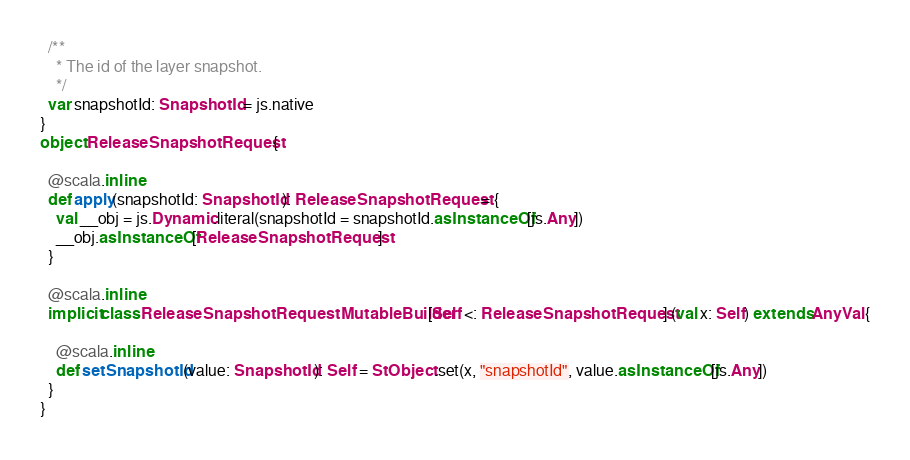Convert code to text. <code><loc_0><loc_0><loc_500><loc_500><_Scala_>  /**
    * The id of the layer snapshot.
    */
  var snapshotId: SnapshotId = js.native
}
object ReleaseSnapshotRequest {
  
  @scala.inline
  def apply(snapshotId: SnapshotId): ReleaseSnapshotRequest = {
    val __obj = js.Dynamic.literal(snapshotId = snapshotId.asInstanceOf[js.Any])
    __obj.asInstanceOf[ReleaseSnapshotRequest]
  }
  
  @scala.inline
  implicit class ReleaseSnapshotRequestMutableBuilder[Self <: ReleaseSnapshotRequest] (val x: Self) extends AnyVal {
    
    @scala.inline
    def setSnapshotId(value: SnapshotId): Self = StObject.set(x, "snapshotId", value.asInstanceOf[js.Any])
  }
}
</code> 